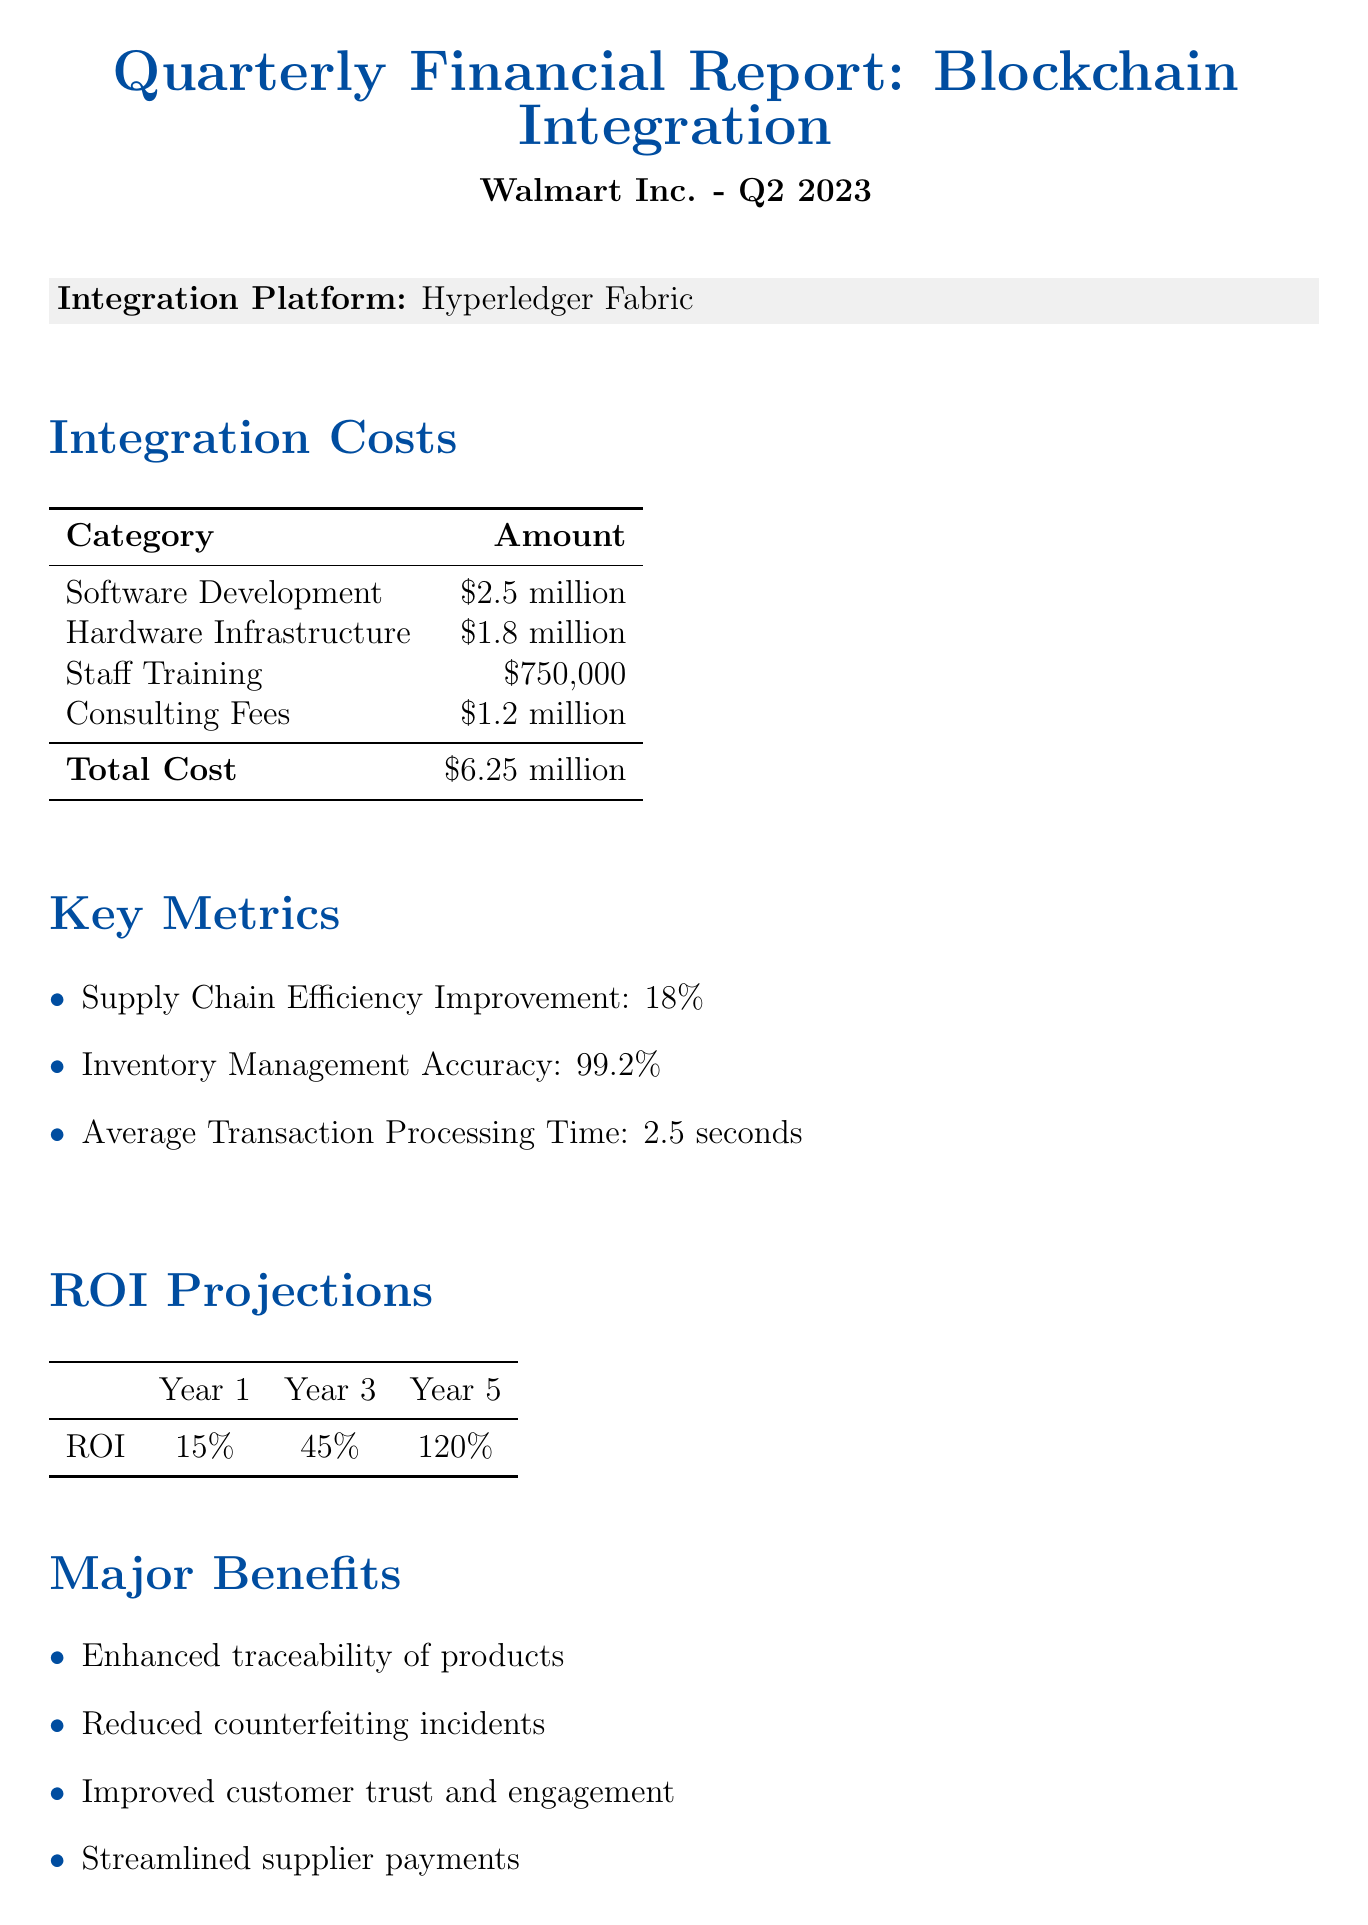What is the total cost of integration? The total cost of integration is provided in the document under integration costs, which amounts to $6.25 million.
Answer: $6.25 million What is the inventory management accuracy? The inventory management accuracy is stated in the key metrics section, which indicates an accuracy of 99.2%.
Answer: 99.2% Which blockchain platform is used? The document specifies the blockchain platform utilized for integration, which is Hyperledger Fabric.
Answer: Hyperledger Fabric What is the projected ROI in Year 5? The projected ROI for Year 5 is found in the ROI projections section, which estimates a return of 120%.
Answer: 120% What major benefit relates to customer engagement? The major benefit concerning customer engagement is highlighted in the document, stating improved customer trust and engagement.
Answer: Improved customer trust and engagement What challenge involves working with suppliers? One of the challenges faced is initial resistance from some suppliers, as indicated in the challenges faced section.
Answer: Initial resistance from some suppliers What future initiative involves smart contracts? The future initiative regarding smart contracts is the implementation of smart contracts for automated supplier agreements.
Answer: Implementation of smart contracts for automated supplier agreements What improvement percentage is noted for supply chain efficiency? The supply chain efficiency improvement percentage is mentioned in the key metrics section, which indicates an improvement of 18%.
Answer: 18% 